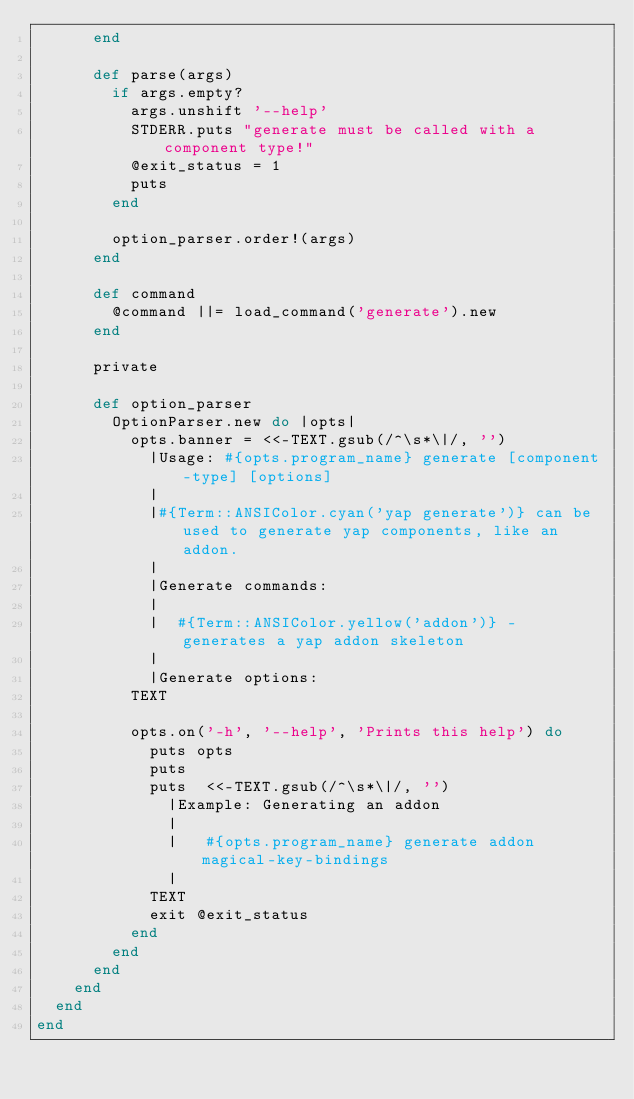<code> <loc_0><loc_0><loc_500><loc_500><_Ruby_>      end

      def parse(args)
        if args.empty?
          args.unshift '--help'
          STDERR.puts "generate must be called with a component type!"
          @exit_status = 1
          puts
        end

        option_parser.order!(args)
      end

      def command
        @command ||= load_command('generate').new
      end

      private

      def option_parser
        OptionParser.new do |opts|
          opts.banner = <<-TEXT.gsub(/^\s*\|/, '')
            |Usage: #{opts.program_name} generate [component-type] [options]
            |
            |#{Term::ANSIColor.cyan('yap generate')} can be used to generate yap components, like an addon.
            |
            |Generate commands:
            |
            |  #{Term::ANSIColor.yellow('addon')} - generates a yap addon skeleton
            |
            |Generate options:
          TEXT

          opts.on('-h', '--help', 'Prints this help') do
            puts opts
            puts
            puts  <<-TEXT.gsub(/^\s*\|/, '')
              |Example: Generating an addon
              |
              |   #{opts.program_name} generate addon magical-key-bindings
              |
            TEXT
            exit @exit_status
          end
        end
      end
    end
  end
end
</code> 